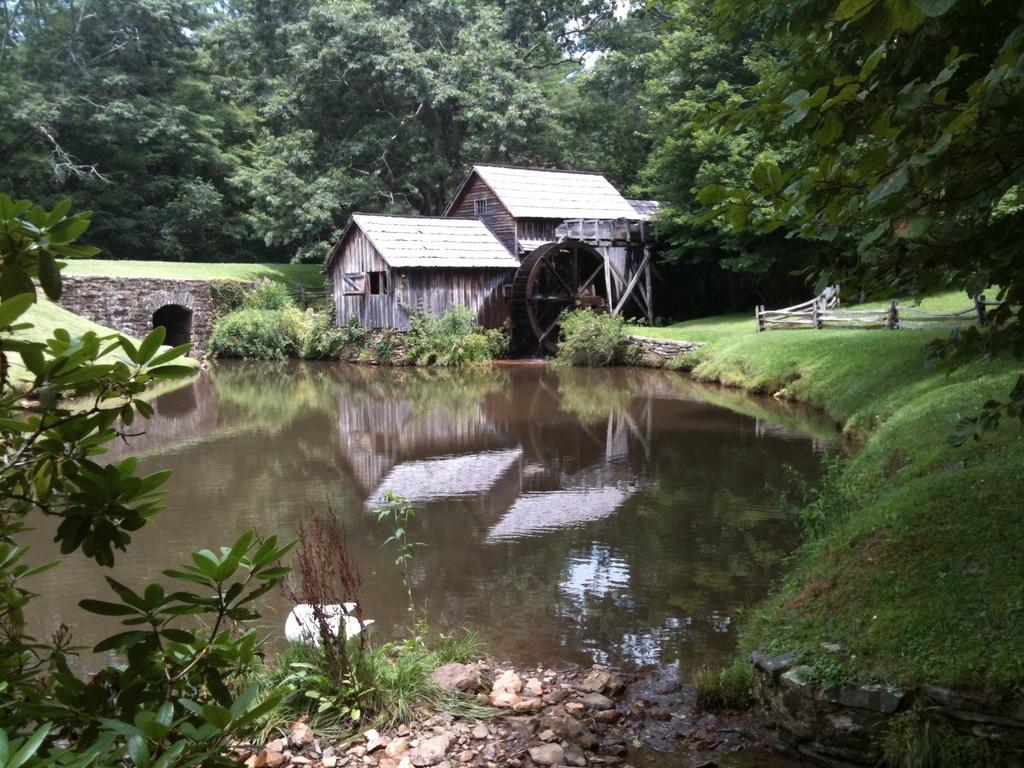How would you summarize this image in a sentence or two? In the foreground of the picture there are stones, grass, plants and water. In the center of the picture there are plants, house, glass, railing. In the background there are trees. 